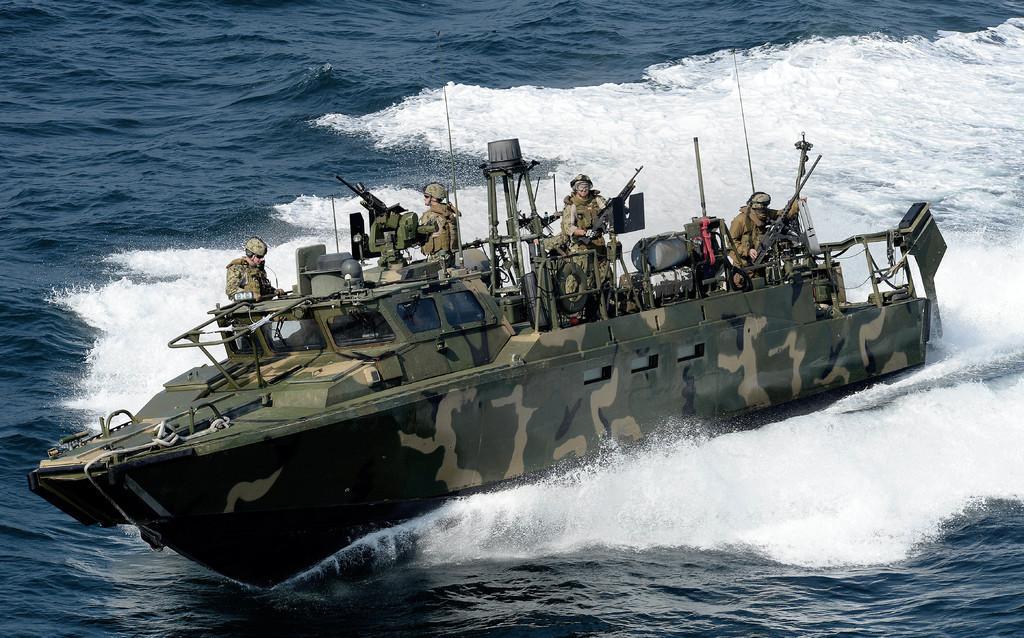Describe this image in one or two sentences. In this image I can see water, military boat and military people. People are holding weapons. In boat there are things. 